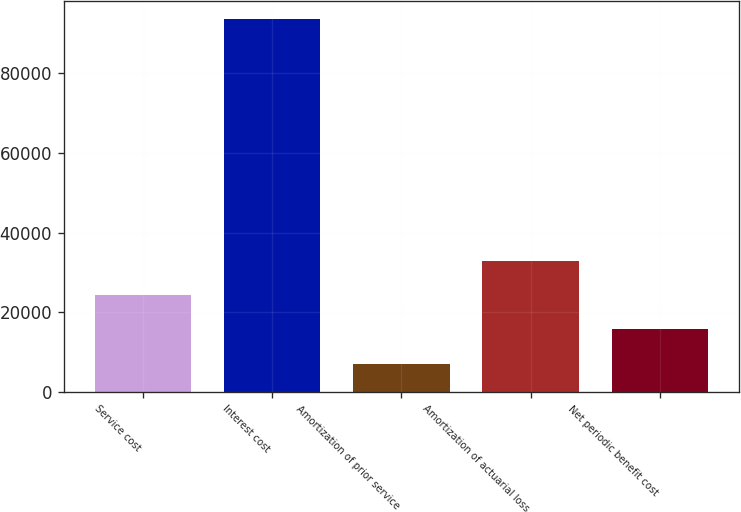Convert chart to OTSL. <chart><loc_0><loc_0><loc_500><loc_500><bar_chart><fcel>Service cost<fcel>Interest cost<fcel>Amortization of prior service<fcel>Amortization of actuarial loss<fcel>Net periodic benefit cost<nl><fcel>24306.6<fcel>93493<fcel>7010<fcel>32954.9<fcel>15658.3<nl></chart> 